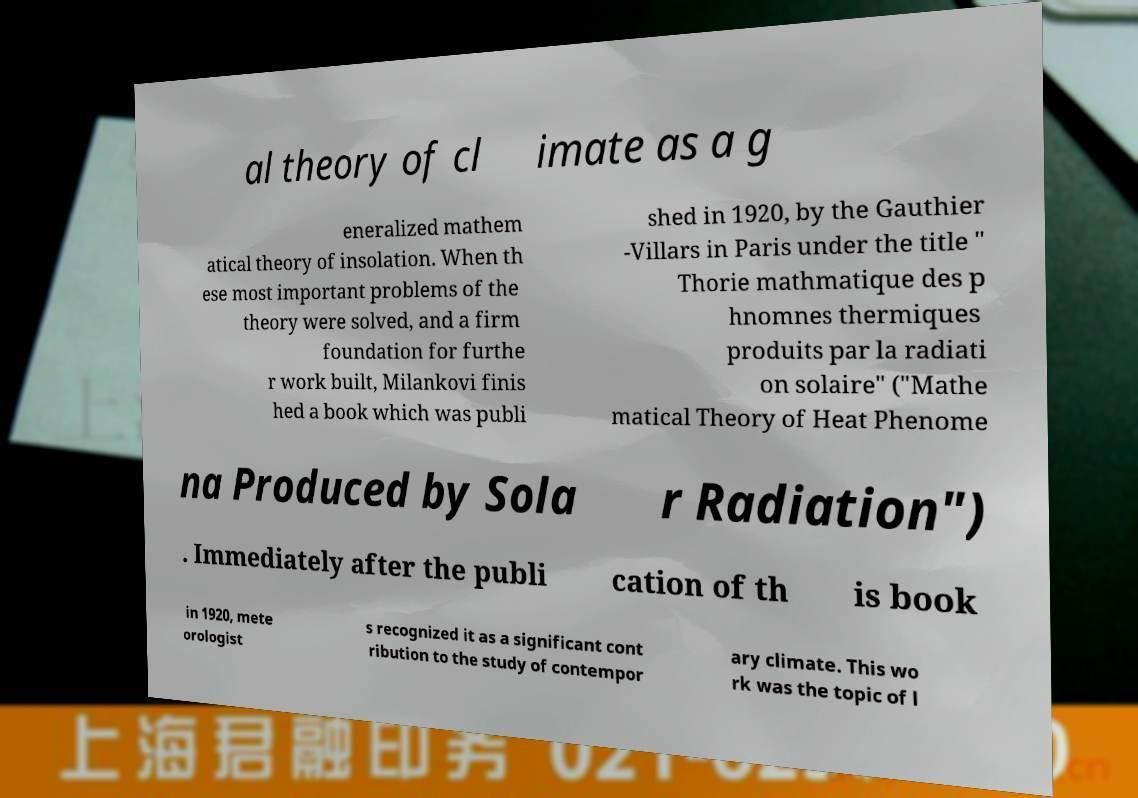Please identify and transcribe the text found in this image. al theory of cl imate as a g eneralized mathem atical theory of insolation. When th ese most important problems of the theory were solved, and a firm foundation for furthe r work built, Milankovi finis hed a book which was publi shed in 1920, by the Gauthier -Villars in Paris under the title " Thorie mathmatique des p hnomnes thermiques produits par la radiati on solaire" ("Mathe matical Theory of Heat Phenome na Produced by Sola r Radiation") . Immediately after the publi cation of th is book in 1920, mete orologist s recognized it as a significant cont ribution to the study of contempor ary climate. This wo rk was the topic of l 